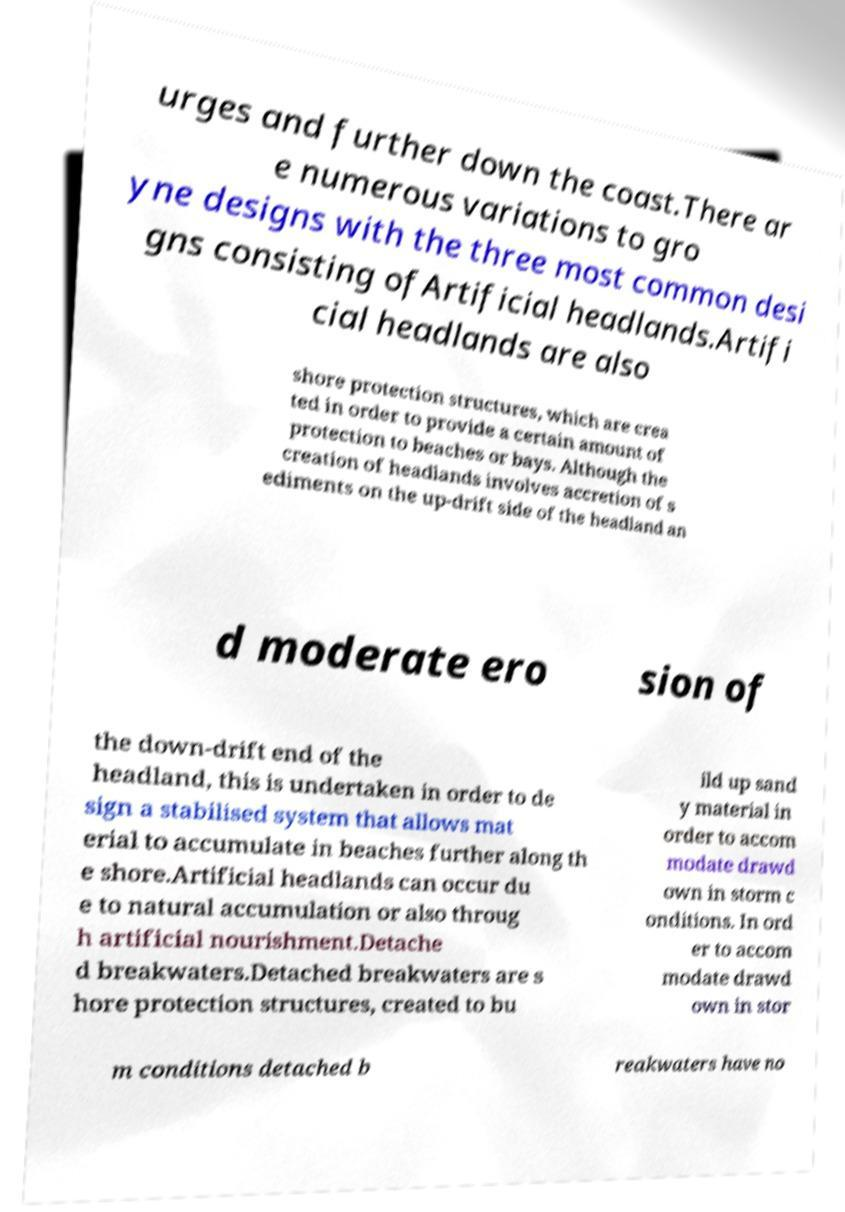Could you assist in decoding the text presented in this image and type it out clearly? urges and further down the coast.There ar e numerous variations to gro yne designs with the three most common desi gns consisting ofArtificial headlands.Artifi cial headlands are also shore protection structures, which are crea ted in order to provide a certain amount of protection to beaches or bays. Although the creation of headlands involves accretion of s ediments on the up-drift side of the headland an d moderate ero sion of the down-drift end of the headland, this is undertaken in order to de sign a stabilised system that allows mat erial to accumulate in beaches further along th e shore.Artificial headlands can occur du e to natural accumulation or also throug h artificial nourishment.Detache d breakwaters.Detached breakwaters are s hore protection structures, created to bu ild up sand y material in order to accom modate drawd own in storm c onditions. In ord er to accom modate drawd own in stor m conditions detached b reakwaters have no 